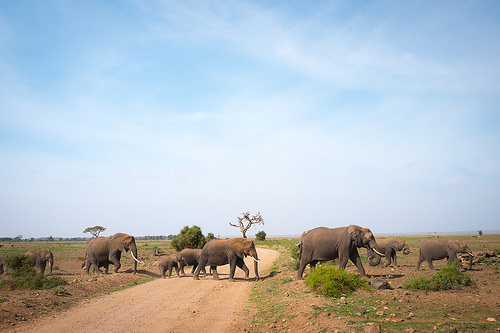<image>
Is there a elephant to the left of the elephant? Yes. From this viewpoint, the elephant is positioned to the left side relative to the elephant. 